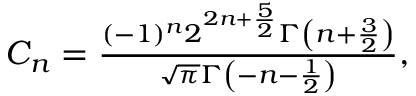Convert formula to latex. <formula><loc_0><loc_0><loc_500><loc_500>\begin{array} { r } { C _ { n } = \frac { ( - 1 ) ^ { n } 2 ^ { 2 n + \frac { 5 } { 2 } } \Gamma \left ( n + \frac { 3 } { 2 } \right ) } { \sqrt { \pi } \Gamma \left ( - n - \frac { 1 } { 2 } \right ) } , } \end{array}</formula> 